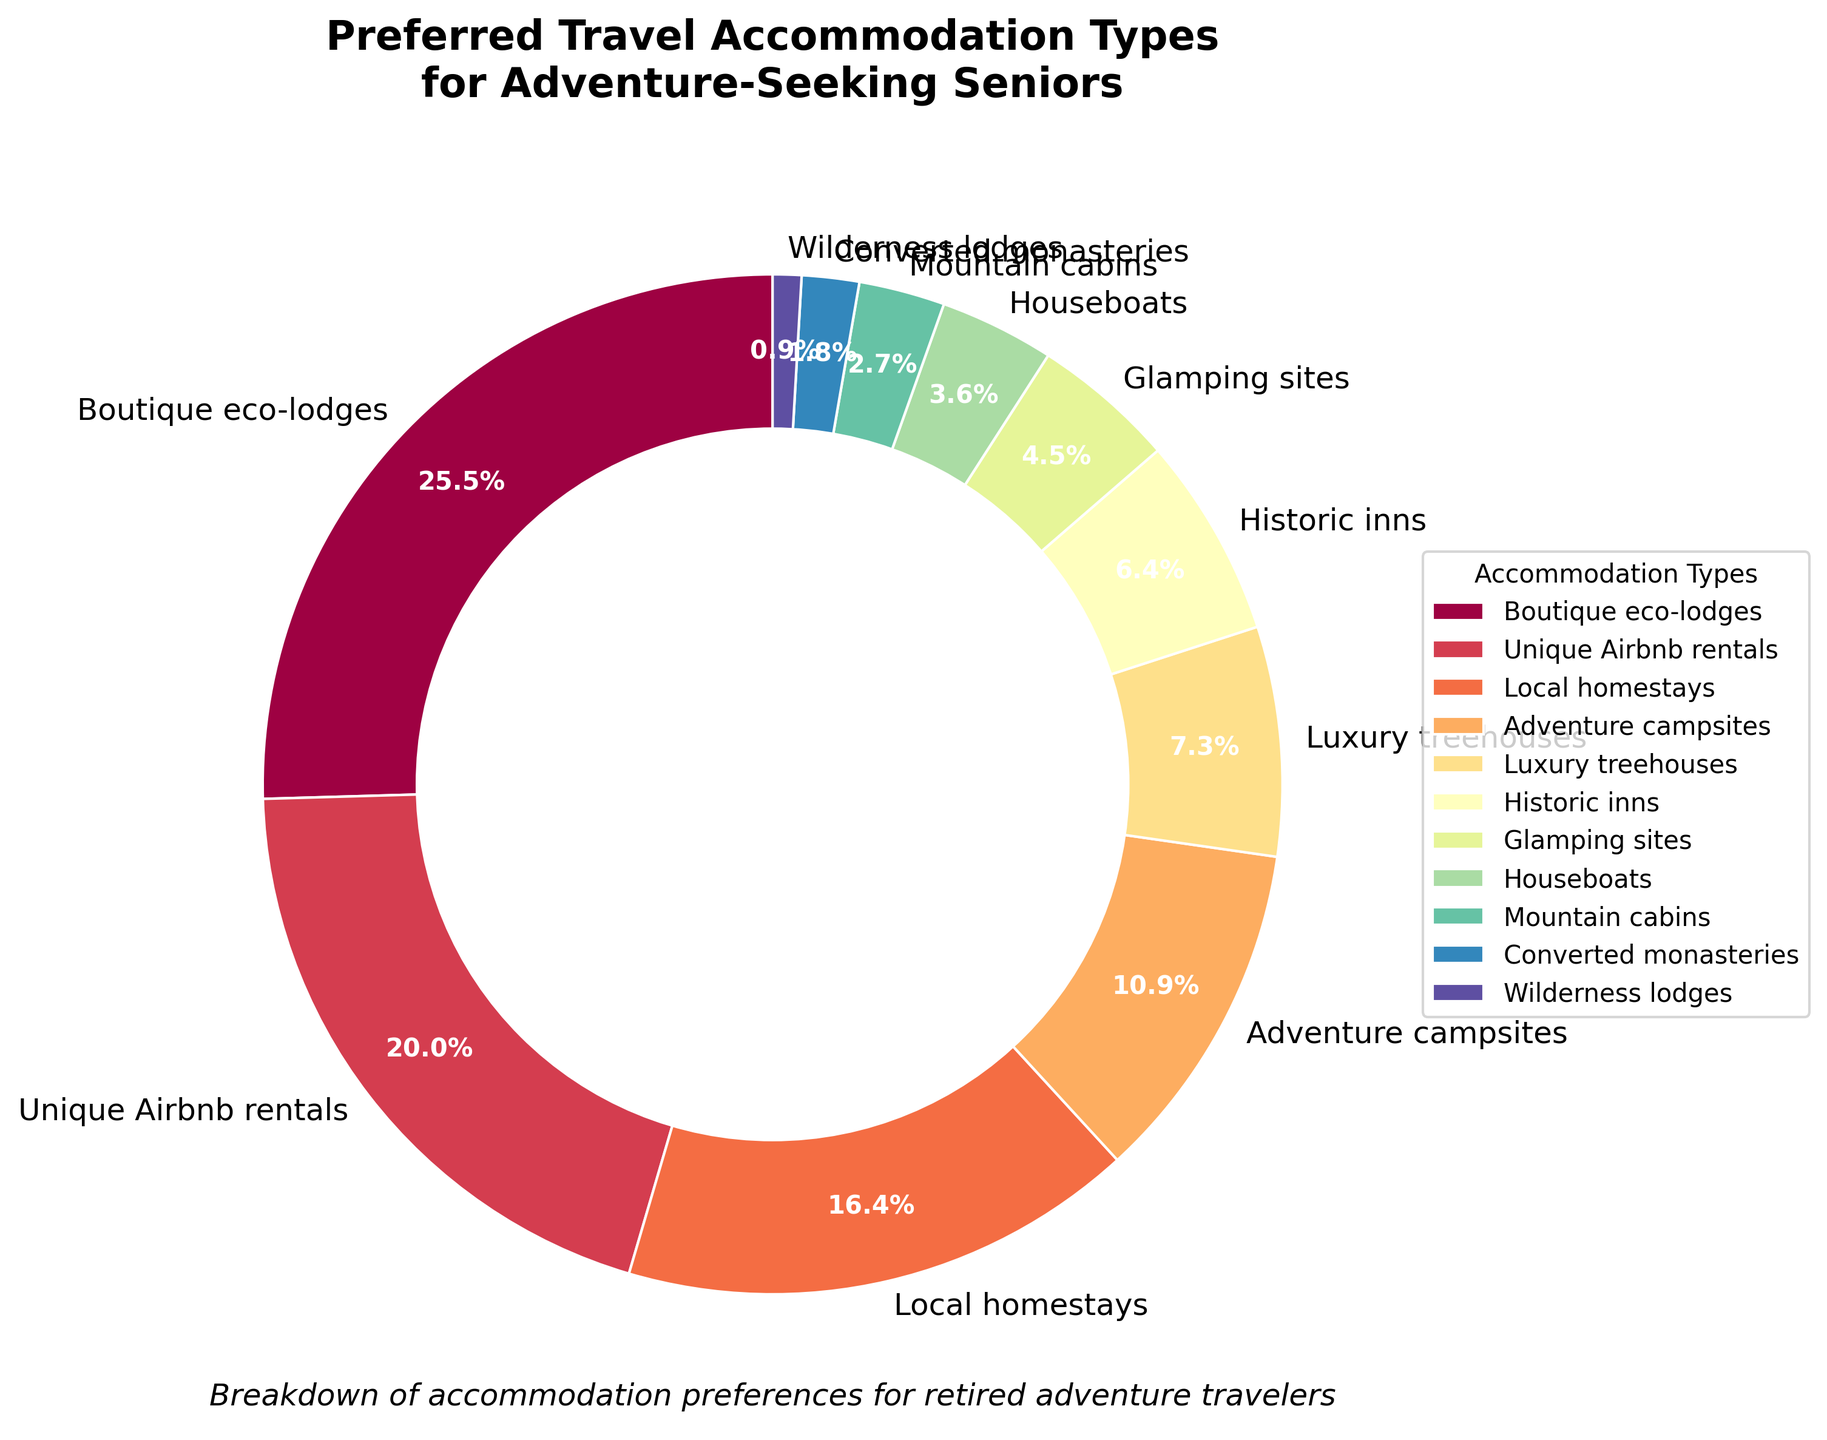Which accommodation type is the most preferred among adventure-seeking seniors? To determine the most preferred accommodation type, we look at the segment with the largest percentage in the pie chart. The largest segment represents Boutique eco-lodges at 28%.
Answer: Boutique eco-lodges Which accommodation types combined account for more than 50% of preferences? We combine the percentages of the top accommodation types until we exceed 50%. Starting with Boutique eco-lodges (28%) and adding Unique Airbnb rentals (22%) gives 50%. Adding the next, Local homestays (18%), brings it to 68%. Therefore, Boutique eco-lodges and Unique Airbnb rentals together exceed 50%.
Answer: Boutique eco-lodges and Unique Airbnb rentals How much more popular are Adventure campsites compared to Historic inns? To find the difference, we subtract the percentage for Historic inns (7%) from the percentage for Adventure campsites (12%). 12% - 7% = 5%.
Answer: 5% What is the total percentage for the four least preferred accommodation types? Adding the percentages for Converted monasteries (2%), Wilderness lodges (1%), Mountain cabins (3%), and Houseboats (4%) gives 2% + 1% + 3% + 4% = 10%.
Answer: 10% Which accommodation type has a percentage closest to Glamping sites? Looking at the percentages, Luxury treehouses have a percentage (8%) closest to Glamping sites (5%), with a difference of 3%.
Answer: Luxury treehouses Are Unique Airbnb rentals more or less popular than Local homestays? By how much? Unique Airbnb rentals are more popular than Local homestays. The difference is calculated by subtracting Local homestays' percentage (18%) from Unique Airbnb rentals' percentage (22%), resulting in 22% - 18% = 4%.
Answer: More popular by 4% If Boutique eco-lodges and Unique Airbnb rentals were combined into a single category, what percentage would they represent together? Adding the percentages for Boutique eco-lodges (28%) and Unique Airbnb rentals (22%) gives 28% + 22% = 50%.
Answer: 50% What is the ratio of people preferring Adventure campsites to those preferring Historic inns? The ratio is found by dividing the percentage for Adventure campsites (12%) by the percentage for Historic inns (7%). Thus, 12% / 7% simplifies approximately to 12:7 or approximately 1.7:1.
Answer: Approximately 1.7:1 How many accommodation types have a preference percentage lower than 5%? Counting the accommodation types with less than 5% leads us to Houseboats (4%), Mountain cabins (3%), Converted monasteries (2%), and Wilderness lodges (1%), totaling four types.
Answer: Four types 